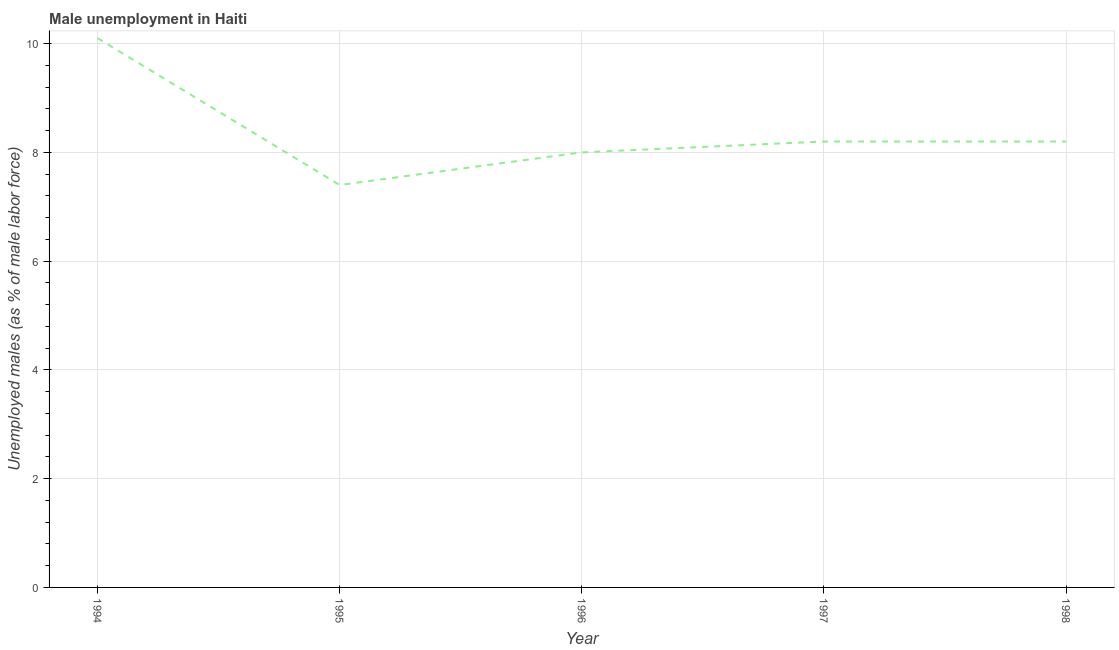What is the unemployed males population in 1997?
Offer a very short reply. 8.2. Across all years, what is the maximum unemployed males population?
Your answer should be very brief. 10.1. Across all years, what is the minimum unemployed males population?
Your answer should be very brief. 7.4. In which year was the unemployed males population minimum?
Provide a succinct answer. 1995. What is the sum of the unemployed males population?
Provide a short and direct response. 41.9. What is the difference between the unemployed males population in 1994 and 1995?
Your answer should be compact. 2.7. What is the average unemployed males population per year?
Give a very brief answer. 8.38. What is the median unemployed males population?
Your answer should be compact. 8.2. What is the ratio of the unemployed males population in 1995 to that in 1996?
Make the answer very short. 0.93. What is the difference between the highest and the second highest unemployed males population?
Keep it short and to the point. 1.9. Is the sum of the unemployed males population in 1995 and 1997 greater than the maximum unemployed males population across all years?
Keep it short and to the point. Yes. What is the difference between the highest and the lowest unemployed males population?
Provide a short and direct response. 2.7. Does the unemployed males population monotonically increase over the years?
Make the answer very short. No. How many years are there in the graph?
Keep it short and to the point. 5. What is the title of the graph?
Provide a succinct answer. Male unemployment in Haiti. What is the label or title of the Y-axis?
Provide a succinct answer. Unemployed males (as % of male labor force). What is the Unemployed males (as % of male labor force) in 1994?
Provide a short and direct response. 10.1. What is the Unemployed males (as % of male labor force) in 1995?
Offer a very short reply. 7.4. What is the Unemployed males (as % of male labor force) of 1997?
Provide a succinct answer. 8.2. What is the Unemployed males (as % of male labor force) of 1998?
Ensure brevity in your answer.  8.2. What is the difference between the Unemployed males (as % of male labor force) in 1994 and 1995?
Offer a very short reply. 2.7. What is the difference between the Unemployed males (as % of male labor force) in 1994 and 1997?
Offer a terse response. 1.9. What is the difference between the Unemployed males (as % of male labor force) in 1995 and 1996?
Offer a terse response. -0.6. What is the difference between the Unemployed males (as % of male labor force) in 1995 and 1997?
Your answer should be compact. -0.8. What is the difference between the Unemployed males (as % of male labor force) in 1996 and 1997?
Your answer should be very brief. -0.2. What is the difference between the Unemployed males (as % of male labor force) in 1996 and 1998?
Offer a terse response. -0.2. What is the difference between the Unemployed males (as % of male labor force) in 1997 and 1998?
Offer a very short reply. 0. What is the ratio of the Unemployed males (as % of male labor force) in 1994 to that in 1995?
Your response must be concise. 1.36. What is the ratio of the Unemployed males (as % of male labor force) in 1994 to that in 1996?
Your response must be concise. 1.26. What is the ratio of the Unemployed males (as % of male labor force) in 1994 to that in 1997?
Ensure brevity in your answer.  1.23. What is the ratio of the Unemployed males (as % of male labor force) in 1994 to that in 1998?
Give a very brief answer. 1.23. What is the ratio of the Unemployed males (as % of male labor force) in 1995 to that in 1996?
Your response must be concise. 0.93. What is the ratio of the Unemployed males (as % of male labor force) in 1995 to that in 1997?
Your answer should be very brief. 0.9. What is the ratio of the Unemployed males (as % of male labor force) in 1995 to that in 1998?
Ensure brevity in your answer.  0.9. What is the ratio of the Unemployed males (as % of male labor force) in 1996 to that in 1997?
Offer a very short reply. 0.98. What is the ratio of the Unemployed males (as % of male labor force) in 1996 to that in 1998?
Your answer should be very brief. 0.98. What is the ratio of the Unemployed males (as % of male labor force) in 1997 to that in 1998?
Your answer should be very brief. 1. 